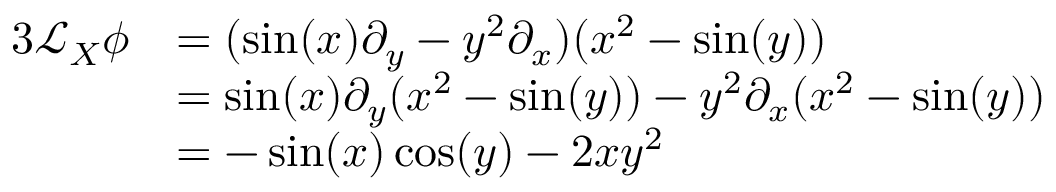Convert formula to latex. <formula><loc_0><loc_0><loc_500><loc_500>{ \begin{array} { r l } { { 3 } { \mathcal { L } } _ { X } \phi } & { = ( \sin ( x ) \partial _ { y } - y ^ { 2 } \partial _ { x } ) ( x ^ { 2 } - \sin ( y ) ) } \\ & { = \sin ( x ) \partial _ { y } ( x ^ { 2 } - \sin ( y ) ) - y ^ { 2 } \partial _ { x } ( x ^ { 2 } - \sin ( y ) ) } \\ & { = - \sin ( x ) \cos ( y ) - 2 x y ^ { 2 } } \end{array} }</formula> 